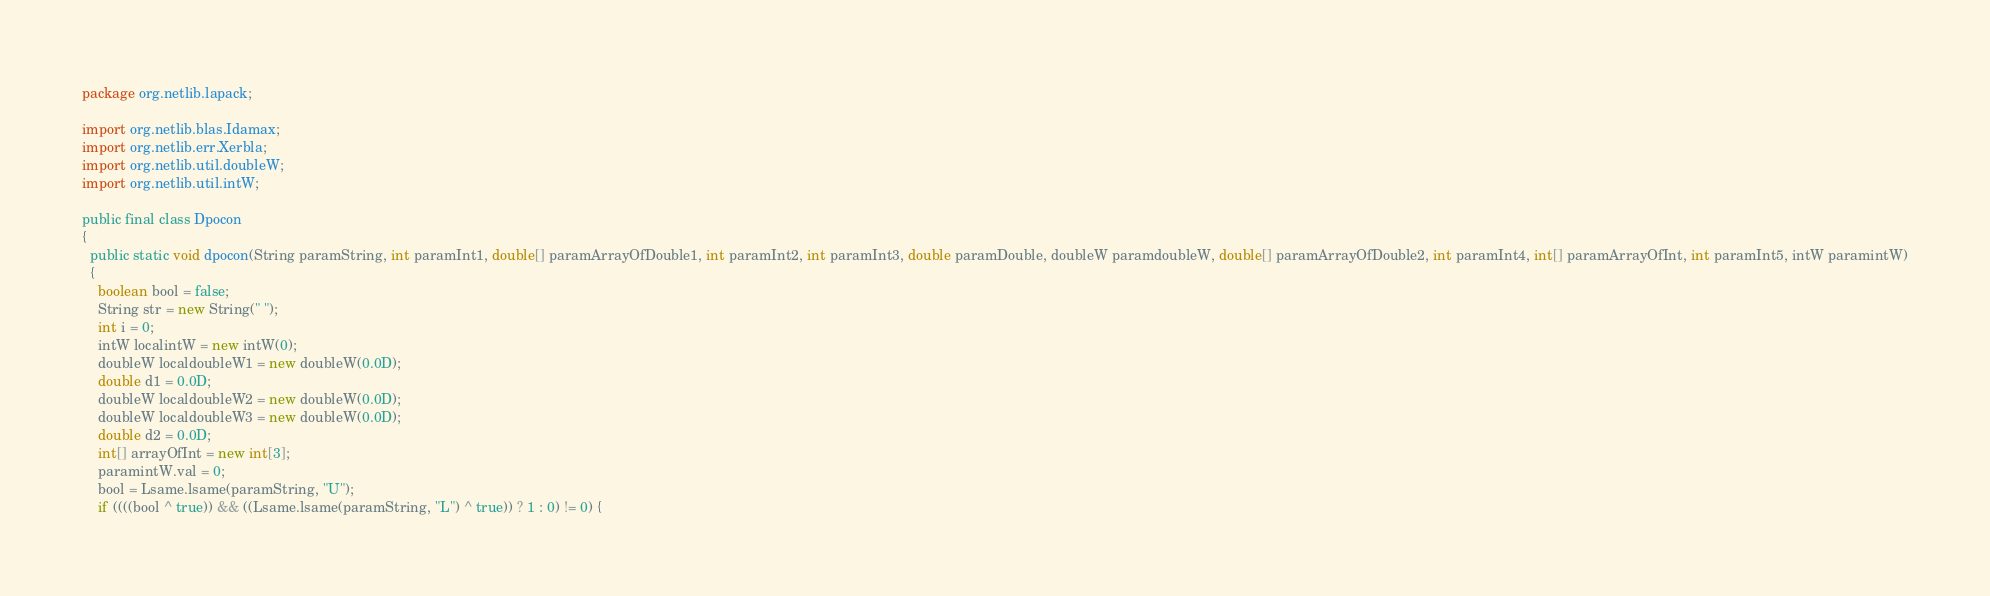Convert code to text. <code><loc_0><loc_0><loc_500><loc_500><_Java_>package org.netlib.lapack;

import org.netlib.blas.Idamax;
import org.netlib.err.Xerbla;
import org.netlib.util.doubleW;
import org.netlib.util.intW;

public final class Dpocon
{
  public static void dpocon(String paramString, int paramInt1, double[] paramArrayOfDouble1, int paramInt2, int paramInt3, double paramDouble, doubleW paramdoubleW, double[] paramArrayOfDouble2, int paramInt4, int[] paramArrayOfInt, int paramInt5, intW paramintW)
  {
    boolean bool = false;
    String str = new String(" ");
    int i = 0;
    intW localintW = new intW(0);
    doubleW localdoubleW1 = new doubleW(0.0D);
    double d1 = 0.0D;
    doubleW localdoubleW2 = new doubleW(0.0D);
    doubleW localdoubleW3 = new doubleW(0.0D);
    double d2 = 0.0D;
    int[] arrayOfInt = new int[3];
    paramintW.val = 0;
    bool = Lsame.lsame(paramString, "U");
    if ((((bool ^ true)) && ((Lsame.lsame(paramString, "L") ^ true)) ? 1 : 0) != 0) {</code> 